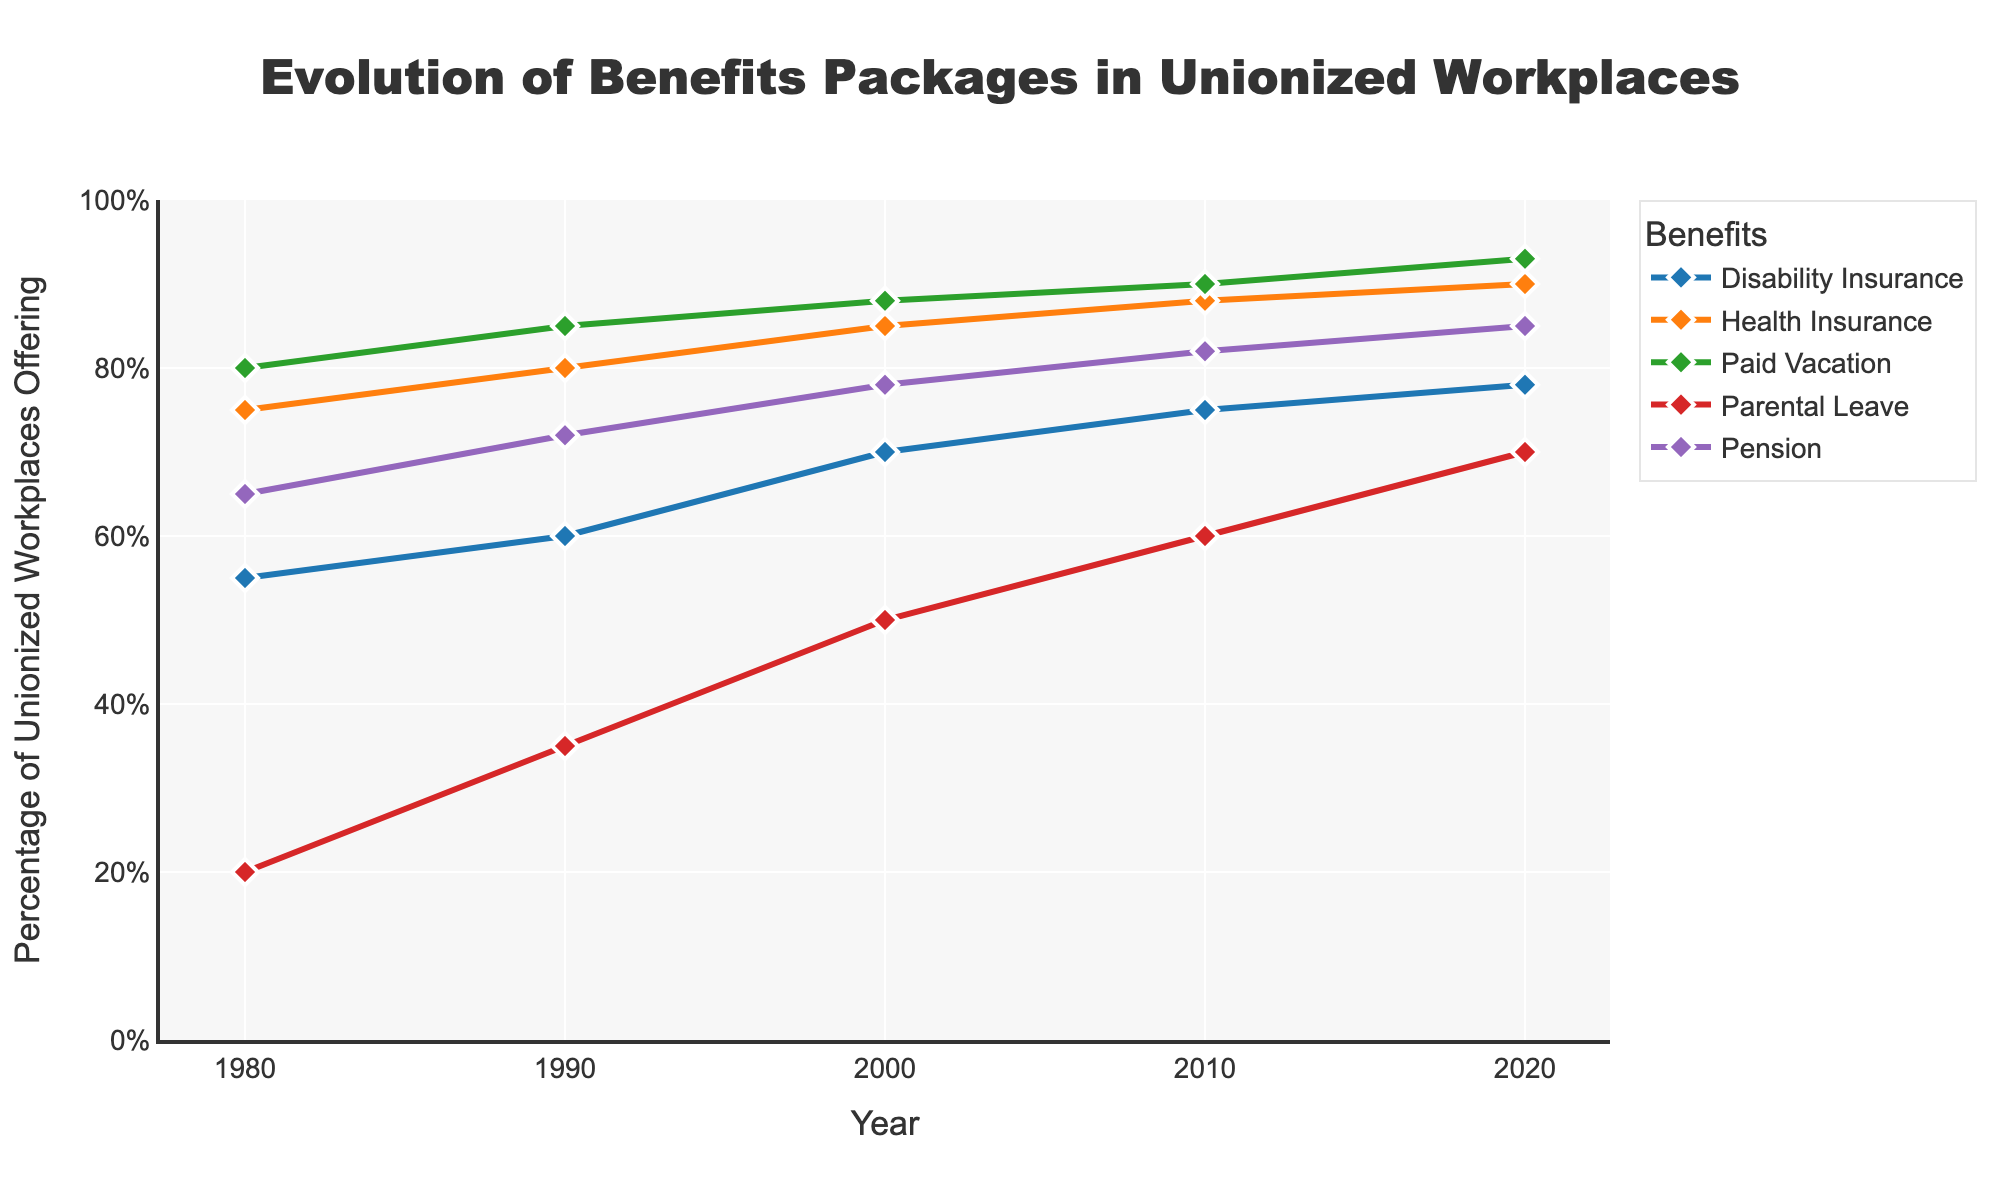What's the title of the figure? The title is prominently displayed at the top of the figure, indicating the topic
Answer: Evolution of Benefits Packages in Unionized Workplaces What years are covered in the time series plot? The x-axis represents years, labeled chronologically from the leftmost year to the rightmost year
Answer: 1980 to 2020 Which benefit had the highest percentage of unionized workplaces offering it in 2020? Look for the benefit line that reaches the highest point on the y-axis in 2020
Answer: Paid Vacation How has the percentage of unionized workplaces offering parental leave changed from 1980 to 2020? Locate the parental leave line and observe its starting point in 1980 and endpoint in 2020
Answer: Increased from 20% to 70% Between 1990 and 2000, which benefit saw the smallest increase in the percentage of unionized workplaces offering it? Compare the differences in the y-values for each benefit between the two years, and identify the smallest increase
Answer: Disability Insurance (from 60% to 70%) Which benefits showed a consistent increase in offering from 1980 to 2020? Follow each benefit's line from 1980 to 2020 and check if it consistently rises
Answer: All benefits (Health Insurance, Pension, Paid Vacation, Disability Insurance, Parental Leave) By how many percentage points did the percentage of unionized workplaces offering Disability Insurance rise from 1980 to 2010? Identify the starting and ending values for Disability Insurance at these two years, then subtract the 1980 value from the 2010 value
Answer: 20 percentage points (from 55% to 75%) What is the difference in percentage of unionized workplaces offering Health Insurance between the year 2000 and 2020? Find and subtract the value for Health Insurance in 2000 from its value in 2020
Answer: 5 percentage points (from 85% to 90%) Which benefit had the smallest percentage of unionized workplaces offering it in 1980? Observe the y-values for all benefits in 1980 and locate the smallest
Answer: Parental Leave In which decade did the percentage of unionized workplaces offering Parental Leave see the largest increase? Check the increments for Parental Leave between each pair of consecutive decades
Answer: 1980 to 1990 (from 20% to 35%) 